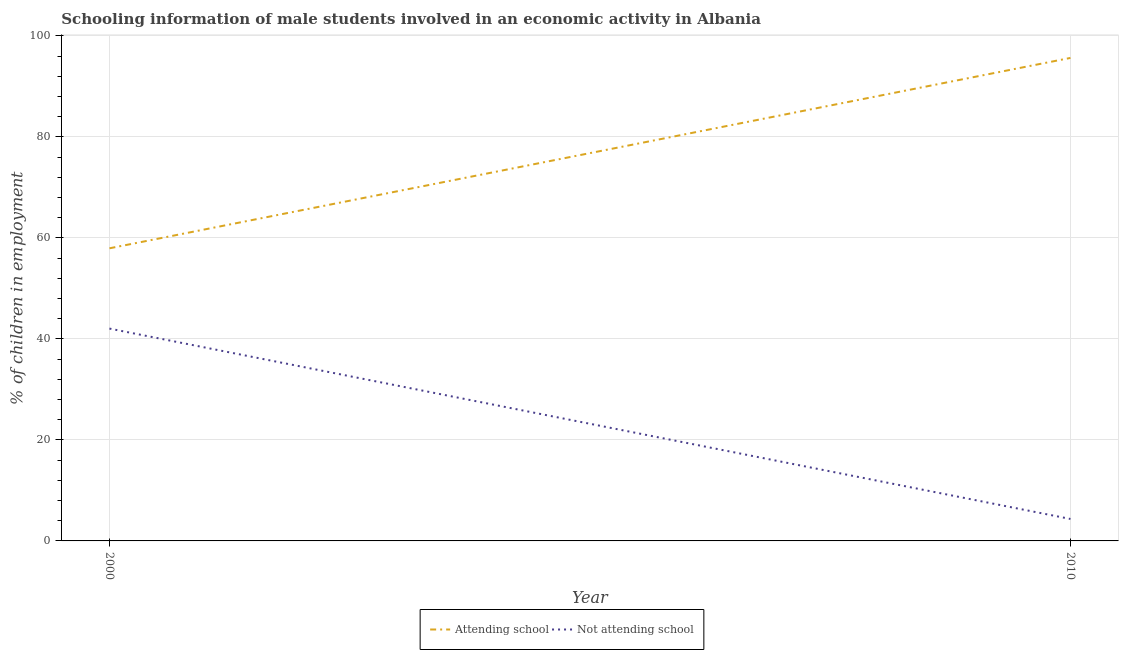What is the percentage of employed males who are not attending school in 2000?
Make the answer very short. 42.05. Across all years, what is the maximum percentage of employed males who are not attending school?
Your response must be concise. 42.05. Across all years, what is the minimum percentage of employed males who are attending school?
Provide a succinct answer. 57.95. In which year was the percentage of employed males who are attending school maximum?
Your response must be concise. 2010. In which year was the percentage of employed males who are attending school minimum?
Give a very brief answer. 2000. What is the total percentage of employed males who are not attending school in the graph?
Provide a short and direct response. 46.4. What is the difference between the percentage of employed males who are attending school in 2000 and that in 2010?
Provide a succinct answer. -37.7. What is the difference between the percentage of employed males who are not attending school in 2010 and the percentage of employed males who are attending school in 2000?
Your answer should be very brief. -53.6. What is the average percentage of employed males who are attending school per year?
Your answer should be compact. 76.8. In the year 2010, what is the difference between the percentage of employed males who are attending school and percentage of employed males who are not attending school?
Provide a succinct answer. 91.31. What is the ratio of the percentage of employed males who are not attending school in 2000 to that in 2010?
Ensure brevity in your answer.  9.67. In how many years, is the percentage of employed males who are attending school greater than the average percentage of employed males who are attending school taken over all years?
Your answer should be compact. 1. Does the percentage of employed males who are not attending school monotonically increase over the years?
Provide a short and direct response. No. Is the percentage of employed males who are not attending school strictly greater than the percentage of employed males who are attending school over the years?
Offer a terse response. No. What is the difference between two consecutive major ticks on the Y-axis?
Provide a short and direct response. 20. Where does the legend appear in the graph?
Give a very brief answer. Bottom center. How many legend labels are there?
Provide a short and direct response. 2. How are the legend labels stacked?
Your response must be concise. Horizontal. What is the title of the graph?
Your answer should be very brief. Schooling information of male students involved in an economic activity in Albania. Does "Measles" appear as one of the legend labels in the graph?
Provide a short and direct response. No. What is the label or title of the X-axis?
Give a very brief answer. Year. What is the label or title of the Y-axis?
Provide a succinct answer. % of children in employment. What is the % of children in employment in Attending school in 2000?
Your answer should be compact. 57.95. What is the % of children in employment of Not attending school in 2000?
Give a very brief answer. 42.05. What is the % of children in employment in Attending school in 2010?
Ensure brevity in your answer.  95.65. What is the % of children in employment of Not attending school in 2010?
Ensure brevity in your answer.  4.35. Across all years, what is the maximum % of children in employment in Attending school?
Make the answer very short. 95.65. Across all years, what is the maximum % of children in employment of Not attending school?
Offer a terse response. 42.05. Across all years, what is the minimum % of children in employment in Attending school?
Make the answer very short. 57.95. Across all years, what is the minimum % of children in employment in Not attending school?
Provide a short and direct response. 4.35. What is the total % of children in employment of Attending school in the graph?
Ensure brevity in your answer.  153.6. What is the total % of children in employment of Not attending school in the graph?
Give a very brief answer. 46.4. What is the difference between the % of children in employment of Attending school in 2000 and that in 2010?
Keep it short and to the point. -37.7. What is the difference between the % of children in employment in Not attending school in 2000 and that in 2010?
Offer a very short reply. 37.7. What is the difference between the % of children in employment in Attending school in 2000 and the % of children in employment in Not attending school in 2010?
Offer a very short reply. 53.6. What is the average % of children in employment in Attending school per year?
Your answer should be very brief. 76.8. What is the average % of children in employment of Not attending school per year?
Your answer should be very brief. 23.2. In the year 2000, what is the difference between the % of children in employment of Attending school and % of children in employment of Not attending school?
Make the answer very short. 15.9. In the year 2010, what is the difference between the % of children in employment of Attending school and % of children in employment of Not attending school?
Provide a succinct answer. 91.31. What is the ratio of the % of children in employment of Attending school in 2000 to that in 2010?
Your answer should be compact. 0.61. What is the ratio of the % of children in employment of Not attending school in 2000 to that in 2010?
Keep it short and to the point. 9.67. What is the difference between the highest and the second highest % of children in employment of Attending school?
Your answer should be compact. 37.7. What is the difference between the highest and the second highest % of children in employment of Not attending school?
Give a very brief answer. 37.7. What is the difference between the highest and the lowest % of children in employment in Attending school?
Your answer should be compact. 37.7. What is the difference between the highest and the lowest % of children in employment in Not attending school?
Make the answer very short. 37.7. 